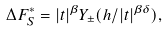Convert formula to latex. <formula><loc_0><loc_0><loc_500><loc_500>\Delta F ^ { * } _ { S } = | t | ^ { \beta } Y _ { \pm } ( h / | t | ^ { \beta \delta } ) ,</formula> 